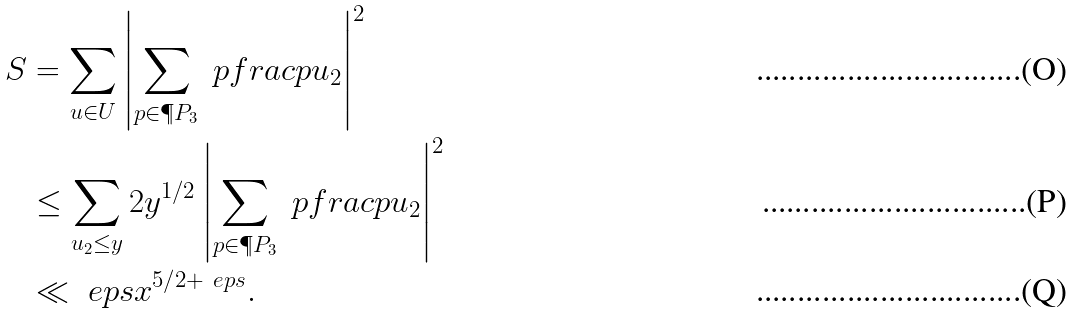<formula> <loc_0><loc_0><loc_500><loc_500>S & = \sum _ { u \in U } \left | \sum _ { p \in \P P _ { 3 } } \ p f r a c { p } { u _ { 2 } } \right | ^ { 2 } \\ & \leq \sum _ { u _ { 2 } \leq y } 2 y ^ { 1 / 2 } \left | \sum _ { p \in \P P _ { 3 } } \ p f r a c { p } { u _ { 2 } } \right | ^ { 2 } \\ & \ll _ { \ } e p s x ^ { 5 / 2 + \ e p s } .</formula> 